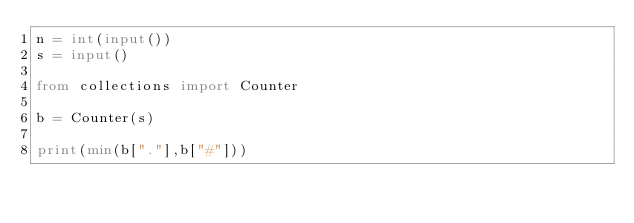Convert code to text. <code><loc_0><loc_0><loc_500><loc_500><_Python_>n = int(input())
s = input()

from collections import Counter

b = Counter(s)

print(min(b["."],b["#"]))</code> 